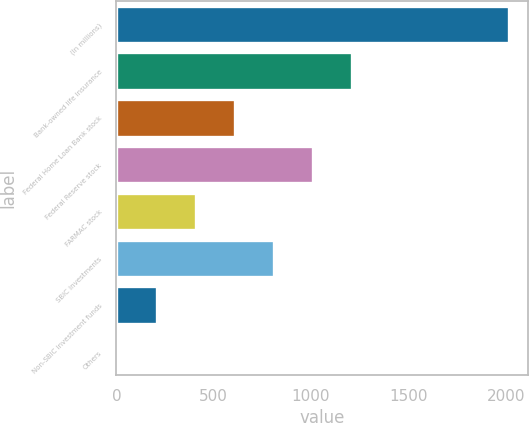Convert chart to OTSL. <chart><loc_0><loc_0><loc_500><loc_500><bar_chart><fcel>(In millions)<fcel>Bank-owned life insurance<fcel>Federal Home Loan Bank stock<fcel>Federal Reserve stock<fcel>FARMAC stock<fcel>SBIC investments<fcel>Non-SBIC investment funds<fcel>Others<nl><fcel>2015<fcel>1212.6<fcel>610.8<fcel>1012<fcel>410.2<fcel>811.4<fcel>209.6<fcel>9<nl></chart> 